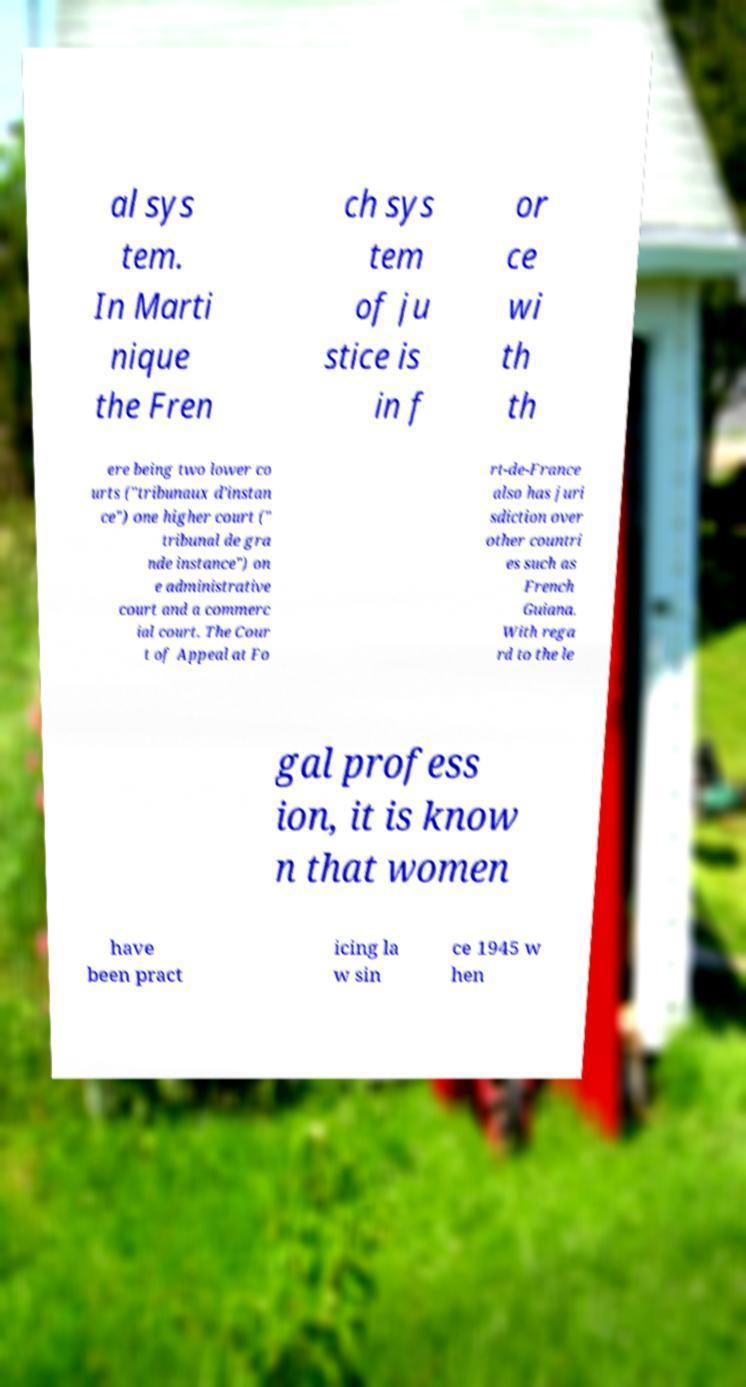There's text embedded in this image that I need extracted. Can you transcribe it verbatim? al sys tem. In Marti nique the Fren ch sys tem of ju stice is in f or ce wi th th ere being two lower co urts ("tribunaux d’instan ce") one higher court (" tribunal de gra nde instance") on e administrative court and a commerc ial court. The Cour t of Appeal at Fo rt-de-France also has juri sdiction over other countri es such as French Guiana. With rega rd to the le gal profess ion, it is know n that women have been pract icing la w sin ce 1945 w hen 